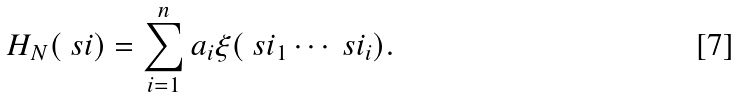<formula> <loc_0><loc_0><loc_500><loc_500>H _ { N } ( \ s i ) = \sum _ { i = 1 } ^ { n } a _ { i } \xi ( \ s i _ { 1 } \cdots \ s i _ { i } ) .</formula> 